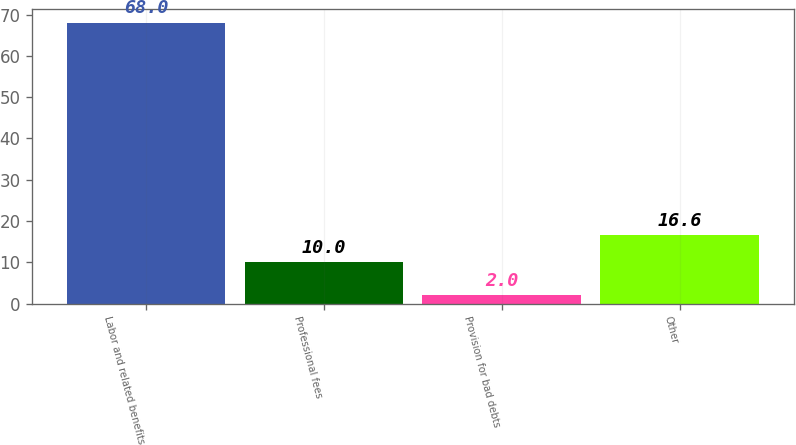Convert chart to OTSL. <chart><loc_0><loc_0><loc_500><loc_500><bar_chart><fcel>Labor and related benefits<fcel>Professional fees<fcel>Provision for bad debts<fcel>Other<nl><fcel>68<fcel>10<fcel>2<fcel>16.6<nl></chart> 